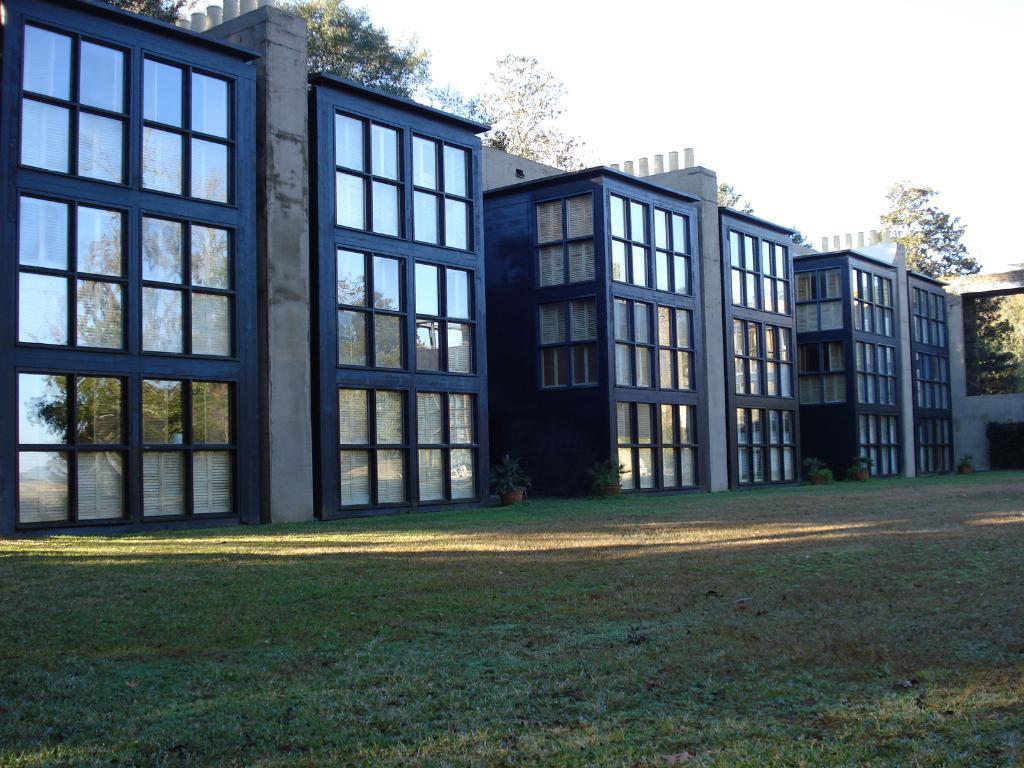Could you give a brief overview of what you see in this image? There are buildings over here with windows, with number of windows. These buildings are constructed in a order, line by line order. There is an open place in front of these buildings with some grass over the land. We can observe a wall here. There are some small plants in front of these buildings. Behind these buildings there are some trees. And in the background we can observe sky. 